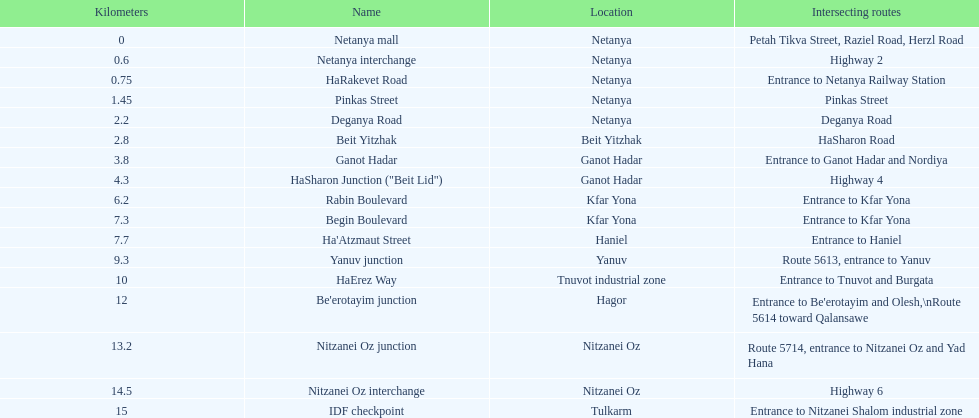How many sections are situated in netanya? 5. 